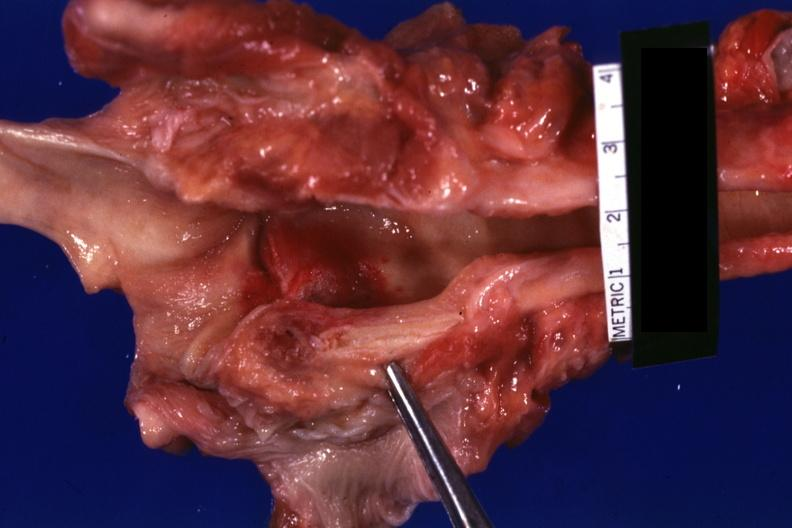how does this image show large ulcer on right cord?
Answer the question using a single word or phrase. With hyperemia case of leukemia with candida infection 